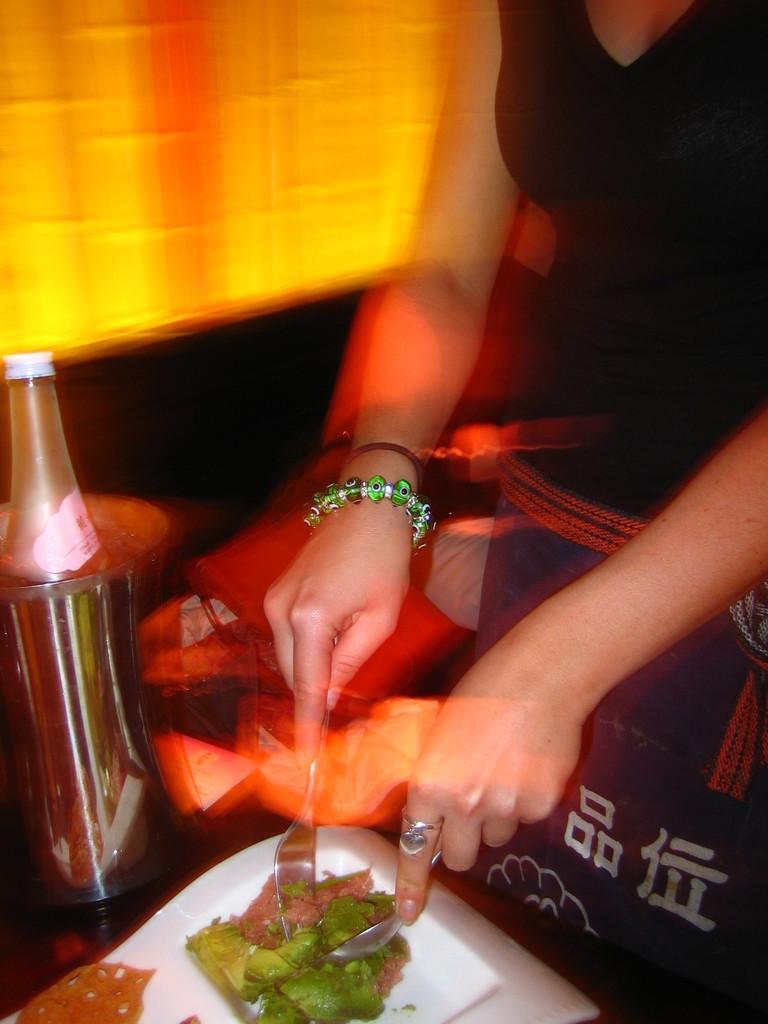In one or two sentences, can you explain what this image depicts? In this image we can see a person holding a spoon and a fork, there is some food on the plate and a bottle on the table and beside the person there is a couch with pillow. 